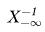<formula> <loc_0><loc_0><loc_500><loc_500>X _ { - \infty } ^ { - 1 }</formula> 